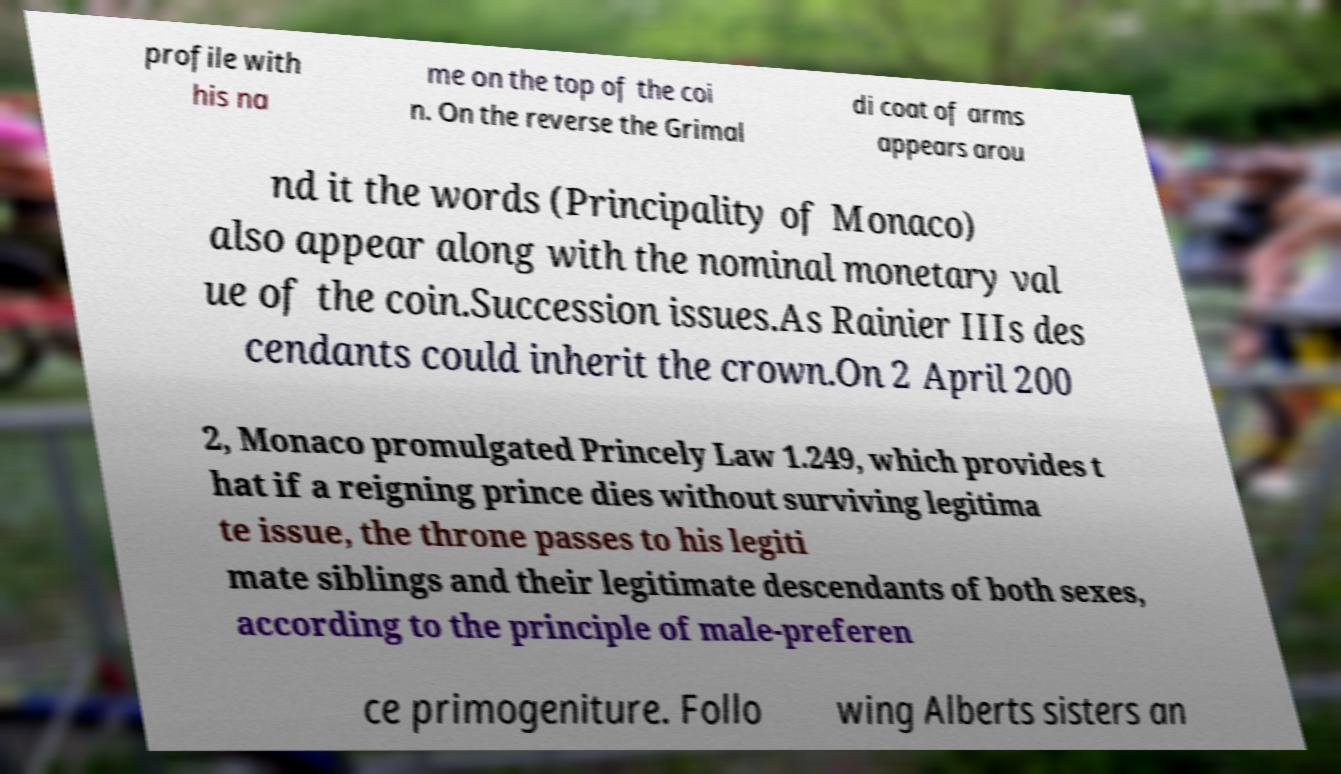Could you assist in decoding the text presented in this image and type it out clearly? profile with his na me on the top of the coi n. On the reverse the Grimal di coat of arms appears arou nd it the words (Principality of Monaco) also appear along with the nominal monetary val ue of the coin.Succession issues.As Rainier IIIs des cendants could inherit the crown.On 2 April 200 2, Monaco promulgated Princely Law 1.249, which provides t hat if a reigning prince dies without surviving legitima te issue, the throne passes to his legiti mate siblings and their legitimate descendants of both sexes, according to the principle of male-preferen ce primogeniture. Follo wing Alberts sisters an 